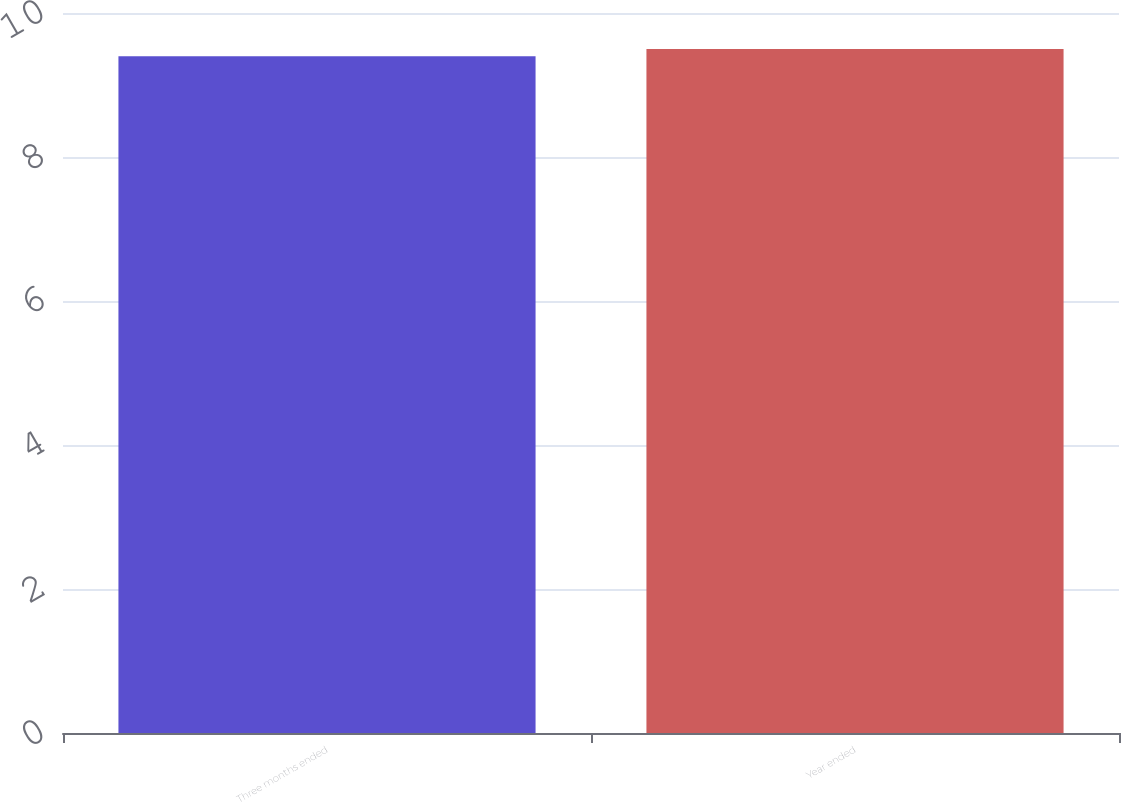Convert chart. <chart><loc_0><loc_0><loc_500><loc_500><bar_chart><fcel>Three months ended<fcel>Year ended<nl><fcel>9.4<fcel>9.5<nl></chart> 